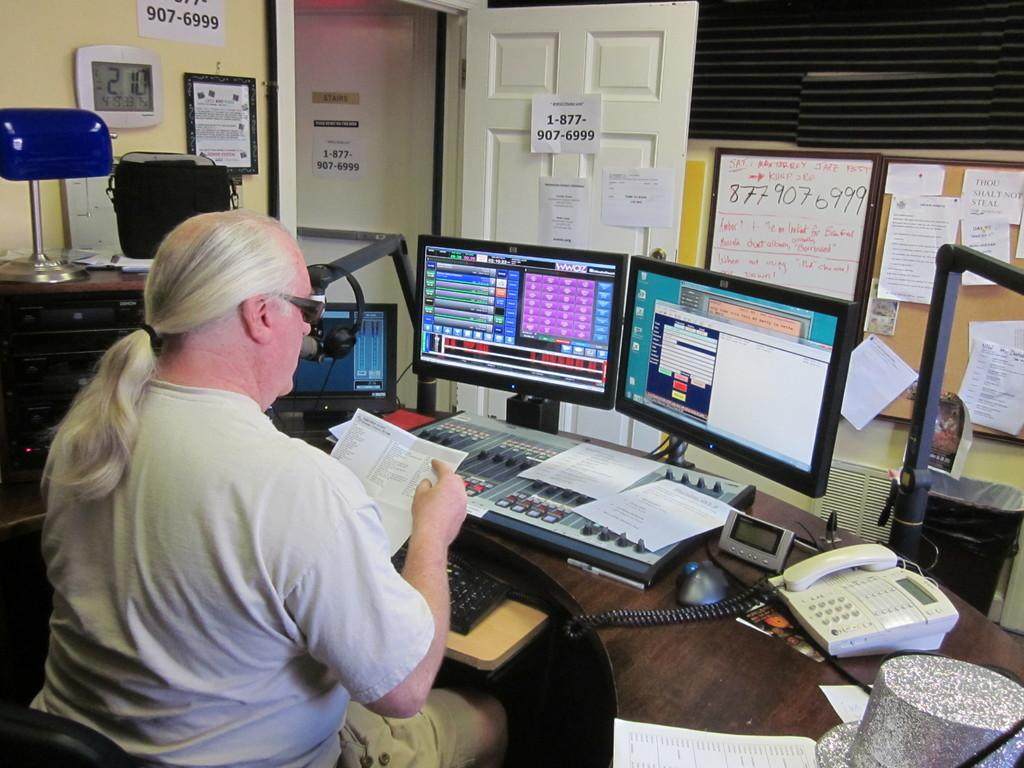<image>
Provide a brief description of the given image. A man works in a studio, with the phone number 1-877-907-6999 posted on the door in front of him. 